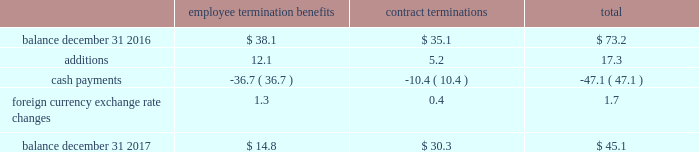Zimmer biomet holdings , inc .
And subsidiaries 2017 form 10-k annual report notes to consolidated financial statements ( continued ) substantially complete .
The table summarizes the liabilities related to these integration plans ( in millions ) : employee termination benefits contract terminations total .
We have also recognized other employee termination benefits related to ldr , other acquisitions and our operational excellence initiatives .
Dedicated project personnel expenses include the salary , benefits , travel expenses and other costs directly associated with employees who are 100 percent dedicated to our integration of acquired businesses , employees who have been notified of termination , but are continuing to work on transferring their responsibilities and employees working on our quality enhancement and remediation efforts and operational excellence initiatives .
Relocated facilities expenses are the moving costs , lease expenses and other facility costs incurred during the relocation period in connection with relocating certain facilities .
Certain litigation matters relate to net expenses recognized during the year for the estimated or actual settlement of certain pending litigation and similar claims , including matters where we recognized income from a settlement on more favorable terms than our previous estimate , or we reduced our estimate of a previously recorded contingent liability .
These litigation matters have included royalty disputes , patent litigation matters , product liability litigation matters and commercial litigation matters .
Contract termination costs relate to terminated agreements in connection with the integration of acquired companies and changes to our distribution model as part of business restructuring and operational excellence initiatives .
The terminated contracts primarily relate to sales agents and distribution agreements .
Information technology integration costs are non- capitalizable costs incurred related to integrating information technology platforms of acquired companies or other significant software implementations as part of our quality and operational excellence initiatives .
As part of the biomet merger , we recognized $ 209.0 million of intangible assets for in-process research and development ( 201cipr&d 201d ) projects .
During 2017 and 2016 , we recorded impairment losses of $ 18.8 million and $ 30.0 million , respectively , related to these ipr&d intangible assets .
The impairments were primarily due to the termination of certain ipr&d projects .
We also recognized $ 479.0 million of intangible assets for trademarks that we designated as having an indefinite life .
During 2017 , we reclassified one of these trademarks to a finite life asset which resulted in an impairment of $ 8.0 million .
Loss/impairment on disposal of assets relates to assets that we have sold or intend to sell , or for which the economic useful life of the asset has been significantly reduced due to integration or our quality and operational excellence initiatives .
Contingent consideration adjustments represent the changes in the fair value of contingent consideration obligations to be paid to the prior owners of acquired businesses .
Certain r&d agreements relate to agreements with upfront payments to obtain intellectual property to be used in r&d projects that have no alternative future use in other projects .
Cash and cash equivalents 2013 we consider all highly liquid investments with an original maturity of three months or less to be cash equivalents .
The carrying amounts reported in the balance sheet for cash and cash equivalents are valued at cost , which approximates their fair value .
Accounts receivable 2013 accounts receivable consists of trade and other miscellaneous receivables .
We grant credit to customers in the normal course of business and maintain an allowance for doubtful accounts for potential credit losses .
We determine the allowance for doubtful accounts by geographic market and take into consideration historical credit experience , creditworthiness of the customer and other pertinent information .
We make concerted efforts to collect all accounts receivable , but sometimes we have to write-off the account against the allowance when we determine the account is uncollectible .
The allowance for doubtful accounts was $ 60.2 million and $ 51.6 million as of december 31 , 2017 and 2016 , respectively .
Inventories 2013 inventories are stated at the lower of cost or market , with cost determined on a first-in first-out basis .
Property , plant and equipment 2013 property , plant and equipment is carried at cost less accumulated depreciation .
Depreciation is computed using the straight-line method based on estimated useful lives of ten to forty years for buildings and improvements and three to eight years for machinery and equipment .
Maintenance and repairs are expensed as incurred .
We review property , plant and equipment for impairment whenever events or changes in circumstances indicate that the carrying value of an asset may not be recoverable .
An impairment loss would be recognized when estimated future undiscounted cash flows relating to the asset are less than its carrying amount .
An impairment loss is measured as the amount by which the carrying amount of an asset exceeds its fair value .
Software costs 2013 we capitalize certain computer software and software development costs incurred in connection with developing or obtaining computer software for internal use when both the preliminary project stage is completed and it is probable that the software will be used as intended .
Capitalized software costs generally include external direct costs of materials and services utilized in developing or obtaining computer software and compensation and related .
What was the net change in the allowance for doubtful accounts between 2016 and 2017 in millions? 
Computations: (60.2 - 51.6)
Answer: 8.6. 